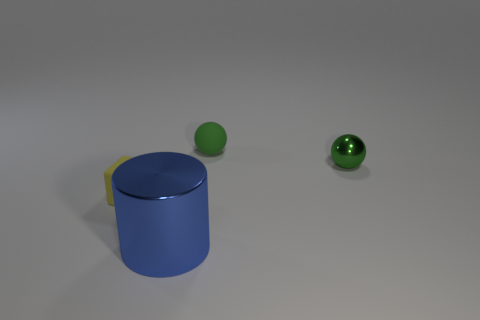What shape is the matte thing that is the same color as the small metallic ball?
Make the answer very short. Sphere. There is a tiny rubber thing that is the same shape as the small green shiny thing; what is its color?
Your answer should be compact. Green. Are there any other things that have the same color as the large cylinder?
Your answer should be very brief. No. Is the size of the green object that is in front of the matte sphere the same as the matte thing that is to the right of the small yellow object?
Provide a succinct answer. Yes. Are there the same number of tiny green metallic things that are in front of the block and metallic balls that are to the left of the large blue metallic object?
Your answer should be very brief. Yes. There is a yellow object; does it have the same size as the metal thing behind the blue metal cylinder?
Ensure brevity in your answer.  Yes. Is there a small sphere that is behind the metal object that is behind the blue cylinder?
Offer a very short reply. Yes. Is there a shiny object of the same shape as the tiny green rubber thing?
Provide a short and direct response. Yes. What number of big shiny cylinders are in front of the rubber object that is to the left of the small matte sphere behind the green shiny object?
Offer a very short reply. 1. Is the color of the small metallic object the same as the rubber thing that is to the right of the large cylinder?
Your answer should be compact. Yes. 